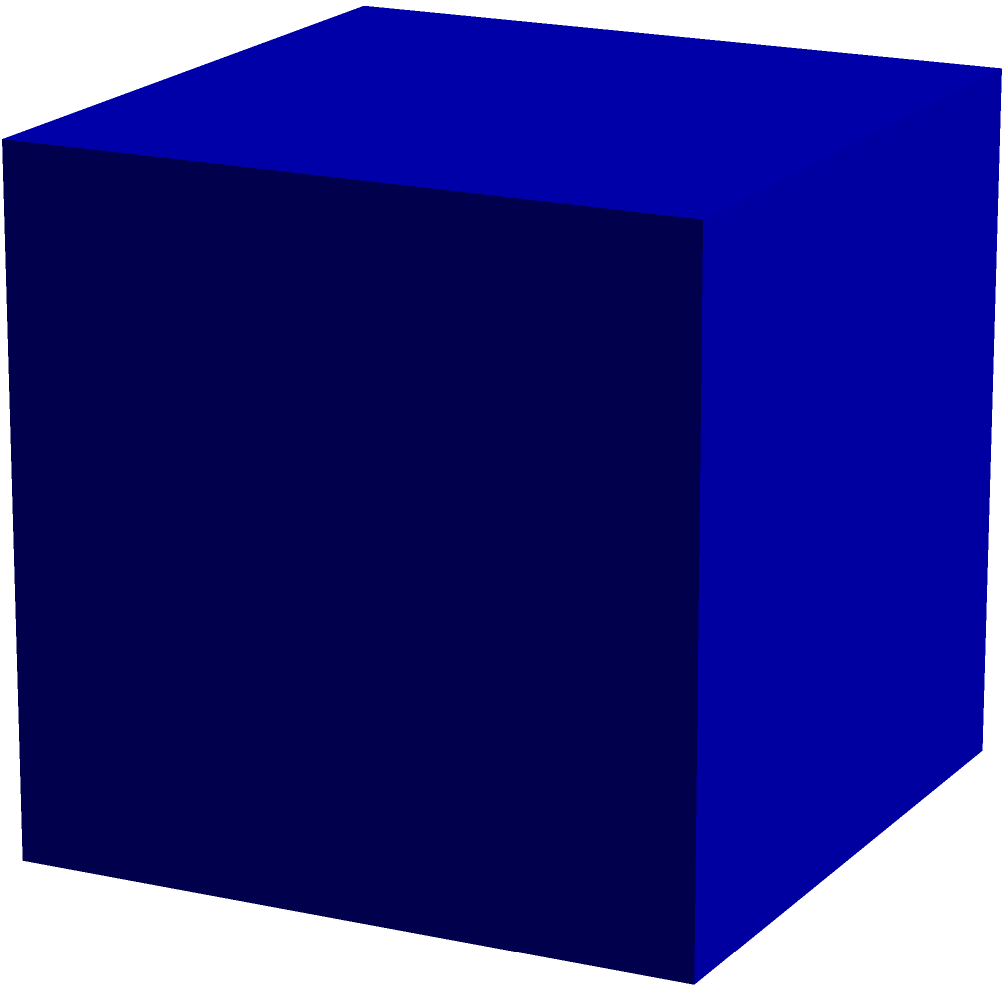While cleaning your attic, you come across an old board game in a cube-shaped box. The side length of the box is 8 inches. What is the total surface area of the box? To find the surface area of a cube-shaped box, we need to:

1. Recall the formula for the surface area of a cube:
   $$SA = 6a^2$$
   where $a$ is the length of one side.

2. We're given that the side length is 8 inches, so $a = 8$.

3. Substitute this value into the formula:
   $$SA = 6(8^2)$$

4. Calculate $8^2$:
   $$SA = 6(64)$$

5. Multiply:
   $$SA = 384$$

Therefore, the total surface area of the board game box is 384 square inches.
Answer: 384 sq in 